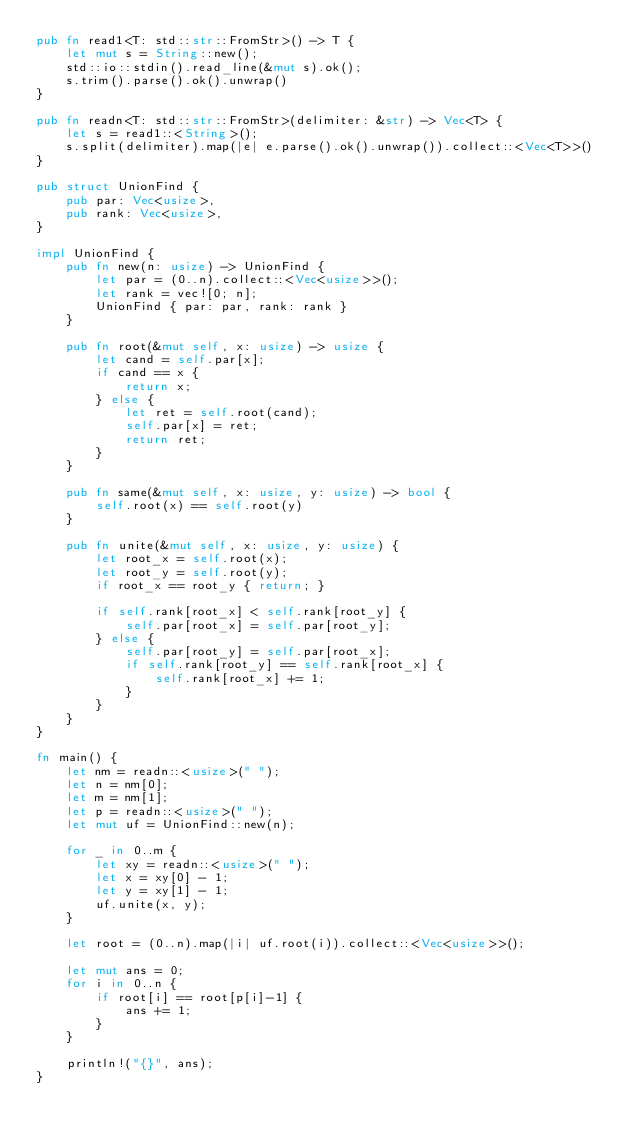<code> <loc_0><loc_0><loc_500><loc_500><_Rust_>pub fn read1<T: std::str::FromStr>() -> T {
    let mut s = String::new();
    std::io::stdin().read_line(&mut s).ok();
    s.trim().parse().ok().unwrap()
}

pub fn readn<T: std::str::FromStr>(delimiter: &str) -> Vec<T> {
    let s = read1::<String>();
    s.split(delimiter).map(|e| e.parse().ok().unwrap()).collect::<Vec<T>>()
}

pub struct UnionFind {
    pub par: Vec<usize>,
    pub rank: Vec<usize>,
}

impl UnionFind {
    pub fn new(n: usize) -> UnionFind {
        let par = (0..n).collect::<Vec<usize>>();
        let rank = vec![0; n];
        UnionFind { par: par, rank: rank }
    }

    pub fn root(&mut self, x: usize) -> usize {
        let cand = self.par[x];
        if cand == x {
            return x;
        } else {
            let ret = self.root(cand);
            self.par[x] = ret;
            return ret;
        }
    }

    pub fn same(&mut self, x: usize, y: usize) -> bool {
        self.root(x) == self.root(y)
    }

    pub fn unite(&mut self, x: usize, y: usize) {
        let root_x = self.root(x);
        let root_y = self.root(y);
        if root_x == root_y { return; }

        if self.rank[root_x] < self.rank[root_y] {
            self.par[root_x] = self.par[root_y];
        } else {
            self.par[root_y] = self.par[root_x];
            if self.rank[root_y] == self.rank[root_x] {
                self.rank[root_x] += 1;
            }
        }
    }
}

fn main() {
    let nm = readn::<usize>(" ");
    let n = nm[0];
    let m = nm[1];
    let p = readn::<usize>(" ");
    let mut uf = UnionFind::new(n);

    for _ in 0..m {
        let xy = readn::<usize>(" ");
        let x = xy[0] - 1;
        let y = xy[1] - 1;
        uf.unite(x, y);
    }

    let root = (0..n).map(|i| uf.root(i)).collect::<Vec<usize>>();

    let mut ans = 0;
    for i in 0..n {
        if root[i] == root[p[i]-1] {
            ans += 1;
        }
    }

    println!("{}", ans);
}</code> 